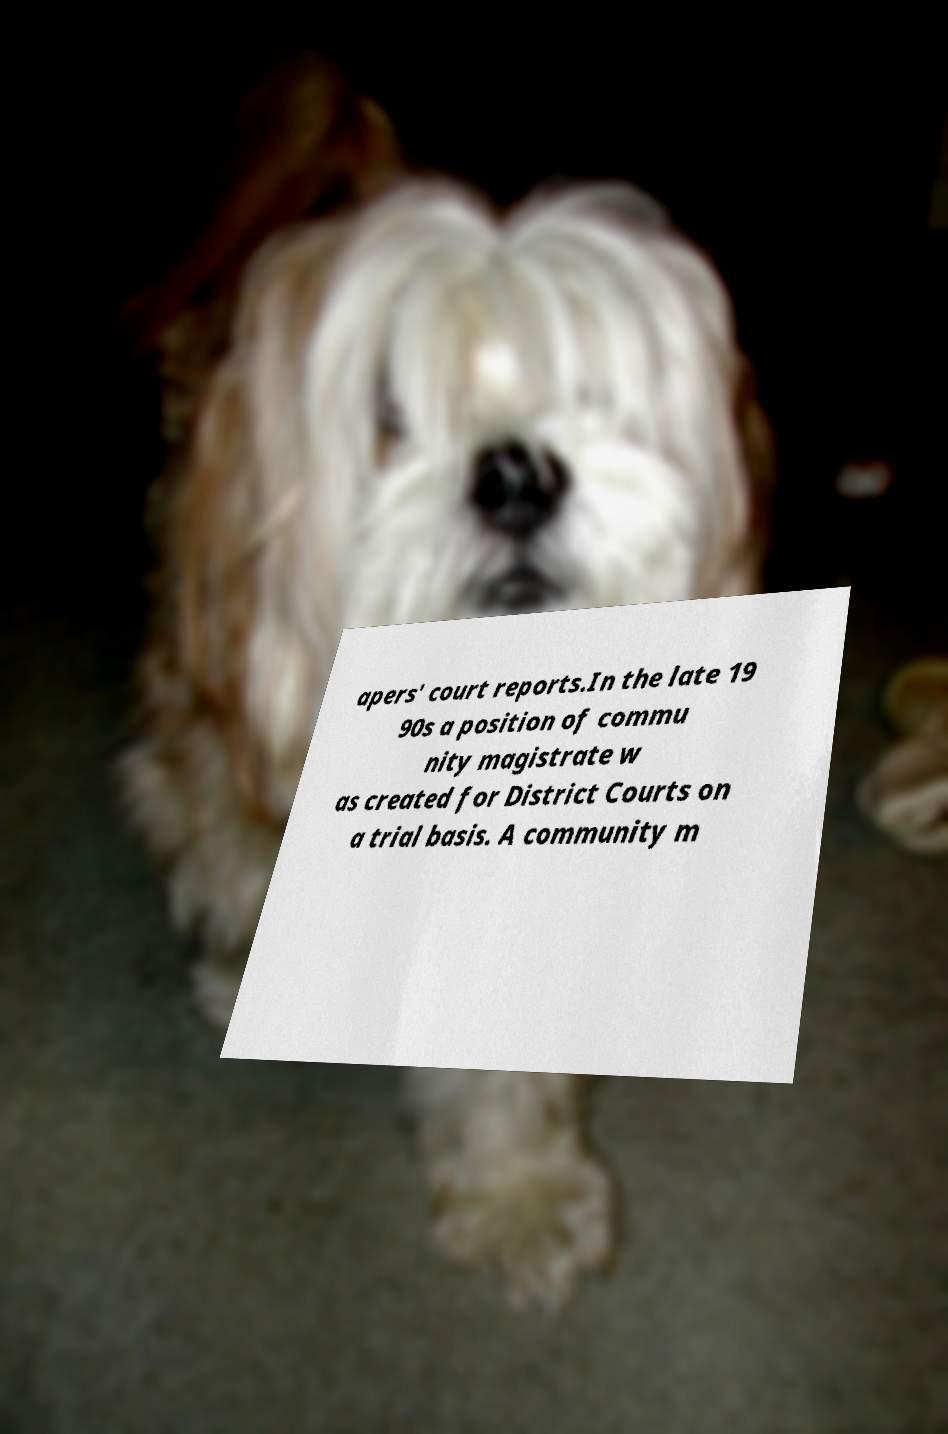Could you assist in decoding the text presented in this image and type it out clearly? apers' court reports.In the late 19 90s a position of commu nity magistrate w as created for District Courts on a trial basis. A community m 